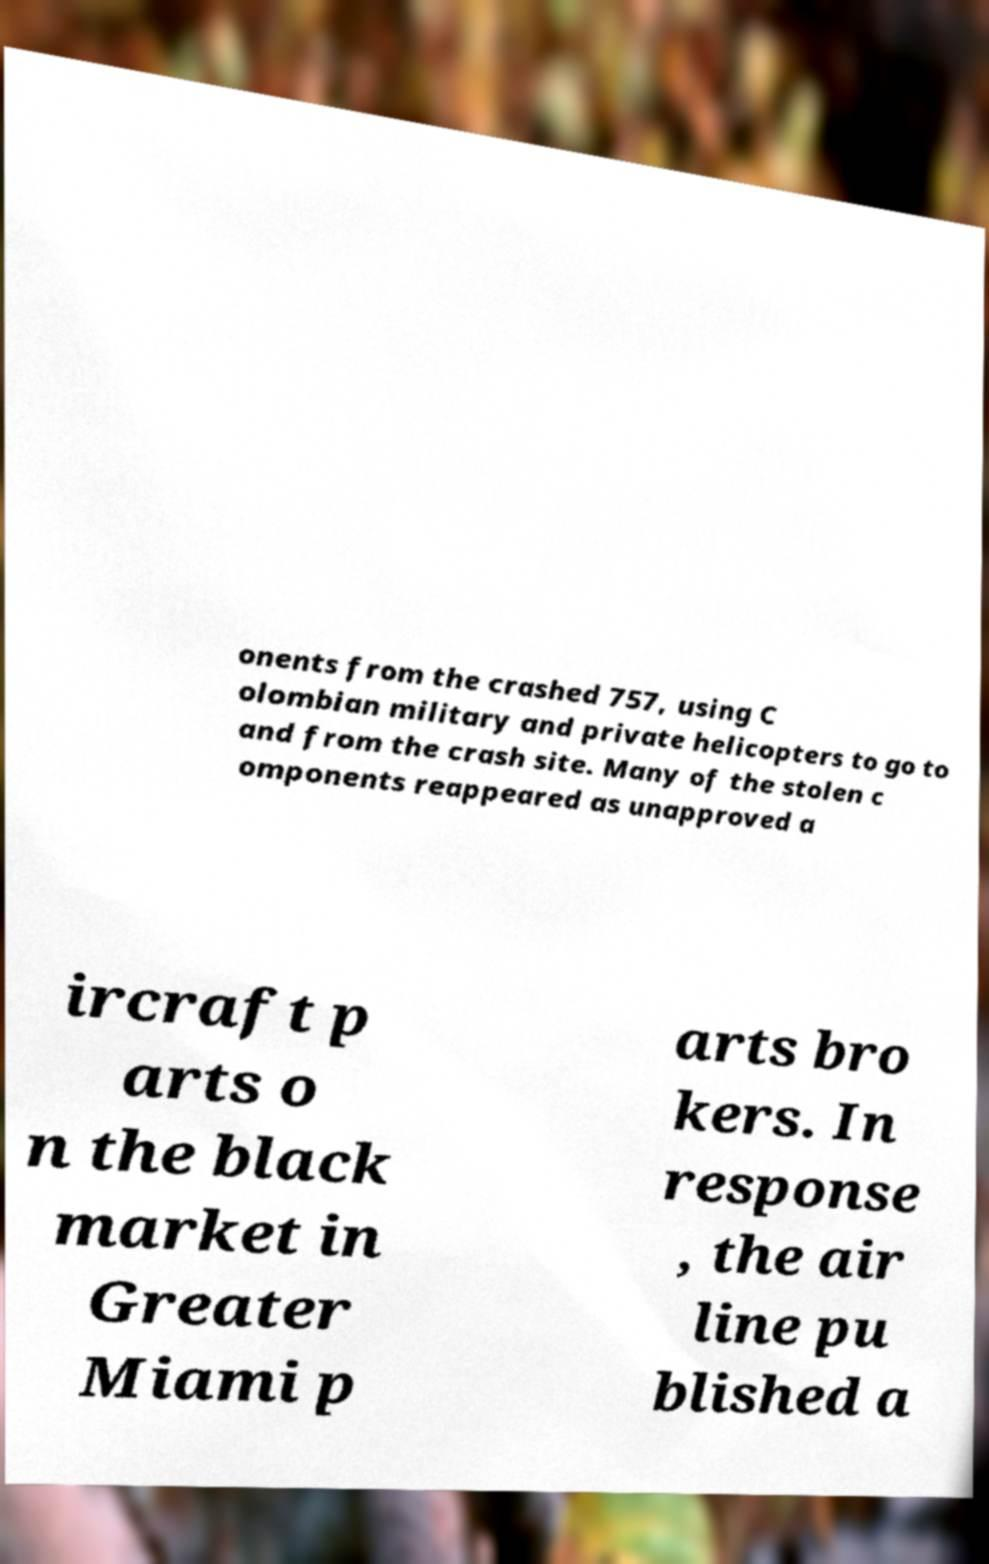Can you read and provide the text displayed in the image?This photo seems to have some interesting text. Can you extract and type it out for me? onents from the crashed 757, using C olombian military and private helicopters to go to and from the crash site. Many of the stolen c omponents reappeared as unapproved a ircraft p arts o n the black market in Greater Miami p arts bro kers. In response , the air line pu blished a 